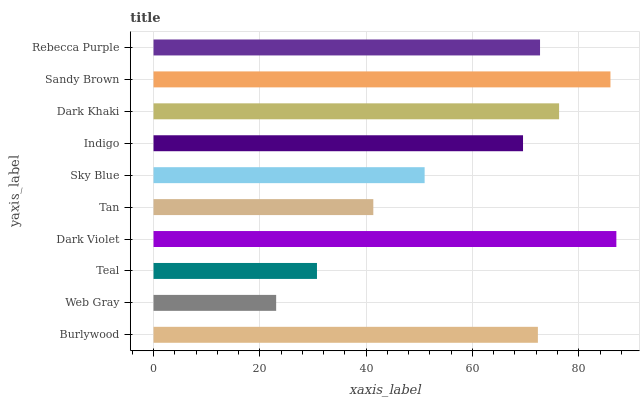Is Web Gray the minimum?
Answer yes or no. Yes. Is Dark Violet the maximum?
Answer yes or no. Yes. Is Teal the minimum?
Answer yes or no. No. Is Teal the maximum?
Answer yes or no. No. Is Teal greater than Web Gray?
Answer yes or no. Yes. Is Web Gray less than Teal?
Answer yes or no. Yes. Is Web Gray greater than Teal?
Answer yes or no. No. Is Teal less than Web Gray?
Answer yes or no. No. Is Burlywood the high median?
Answer yes or no. Yes. Is Indigo the low median?
Answer yes or no. Yes. Is Tan the high median?
Answer yes or no. No. Is Sky Blue the low median?
Answer yes or no. No. 